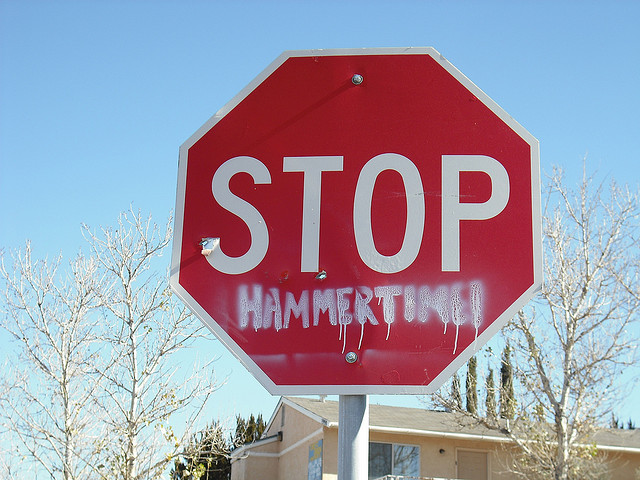Please extract the text content from this image. STOP HAMMERTIME 